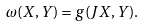<formula> <loc_0><loc_0><loc_500><loc_500>\omega ( X , Y ) = g ( J X , Y ) .</formula> 